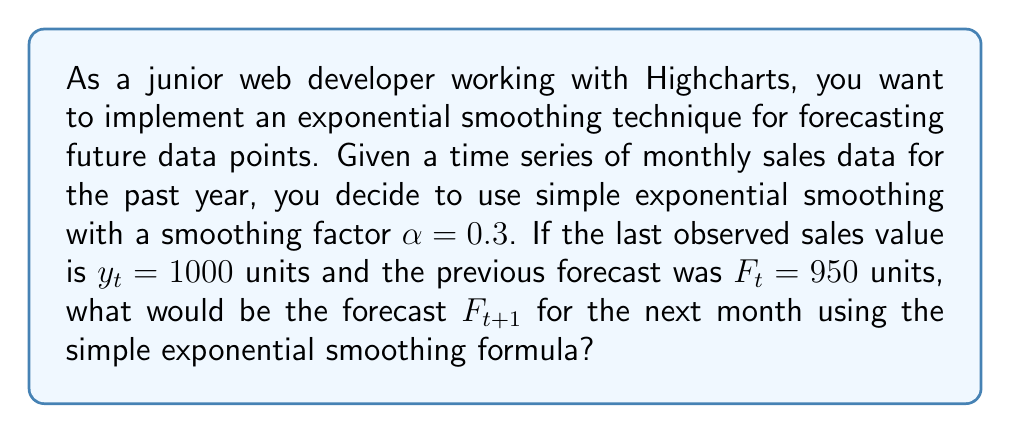Can you answer this question? To solve this problem, we need to understand and apply the simple exponential smoothing formula:

$$F_{t+1} = \alpha y_t + (1 - \alpha)F_t$$

Where:
- $F_{t+1}$ is the forecast for the next period
- $\alpha$ is the smoothing factor (0 < $\alpha$ < 1)
- $y_t$ is the actual observed value at time t
- $F_t$ is the previous forecast for time t

Given:
- $\alpha = 0.3$
- $y_t = 1000$ units
- $F_t = 950$ units

Let's substitute these values into the formula:

$$F_{t+1} = 0.3 \times 1000 + (1 - 0.3) \times 950$$

Now, let's solve step by step:

1. Calculate $\alpha y_t$:
   $0.3 \times 1000 = 300$

2. Calculate $(1 - \alpha)$:
   $1 - 0.3 = 0.7$

3. Calculate $(1 - \alpha)F_t$:
   $0.7 \times 950 = 665$

4. Sum the results from steps 1 and 3:
   $300 + 665 = 965$

Therefore, the forecast for the next month $F_{t+1}$ is 965 units.
Answer: $F_{t+1} = 965$ units 